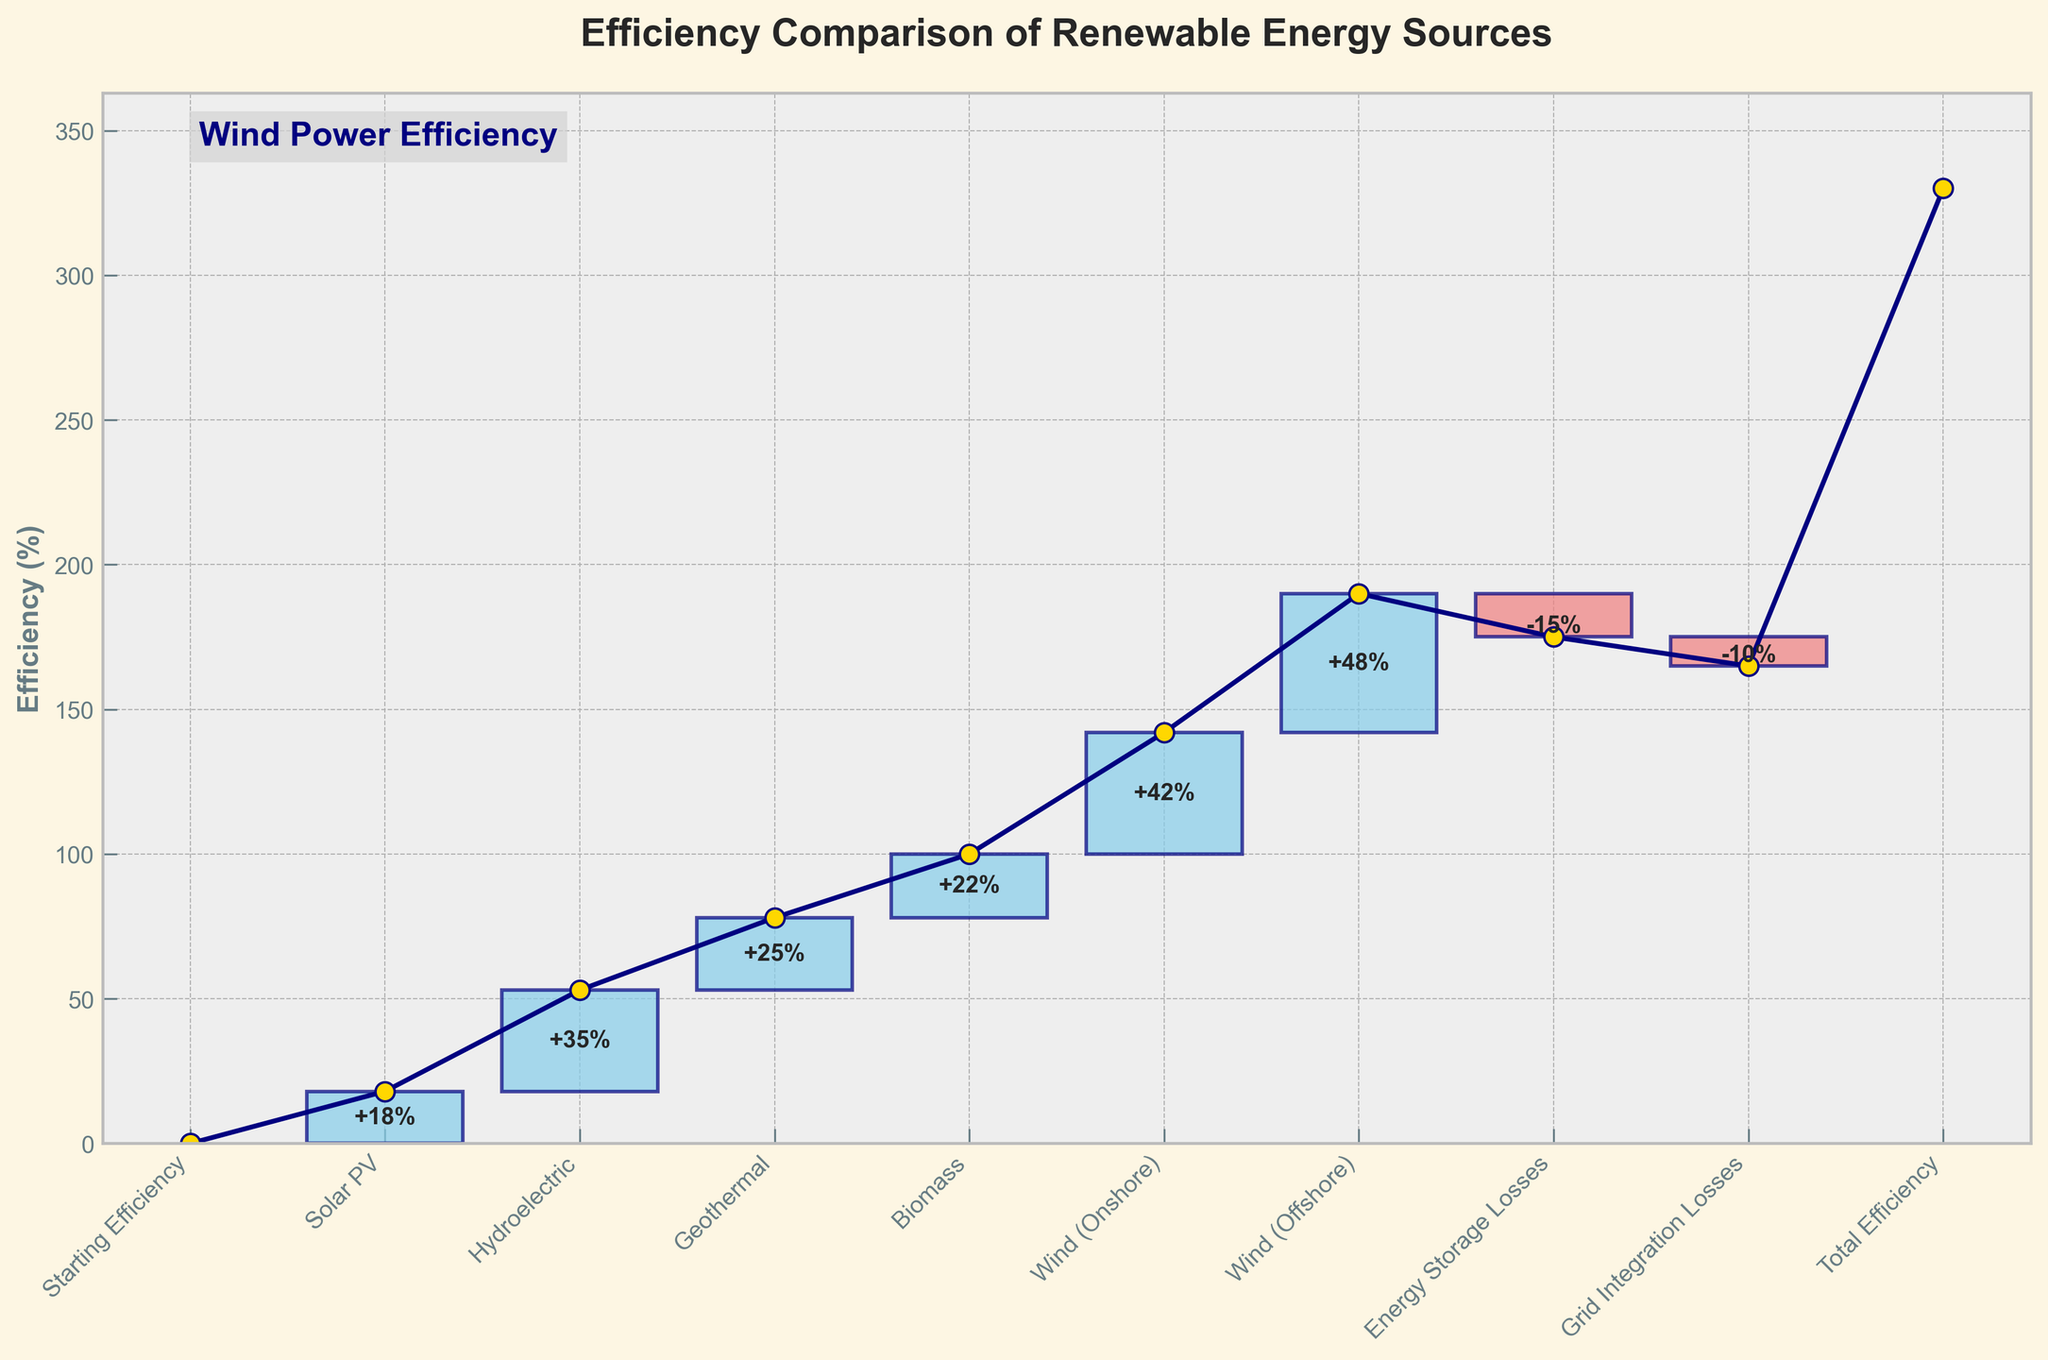Which renewable energy source has the highest efficiency according to the chart? The chart shows multiple renewable sources, but the highest efficiency is associated with the category having the tallest positive bar. From visual inspection, the tallest positive bar represents "Wind (Offshore)" with an efficiency increase of +48%.
Answer: Wind (Offshore) What is the total efficiency of renewable energy sources after considering losses? The chart's final bar represents the "Total Efficiency," combining all gains and losses. This bar ends at 165%, clearly shown on the chart.
Answer: 165% How does the efficiency of onshore wind compare to biomass? The Waterfall Chart shows individual bars for each category. The bar for "Wind (Onshore)" is +42%, while for "Biomass" it is +22%. Comparing these, onshore wind has a higher efficiency by 20%.
Answer: 20% What is the impact of energy storage losses on overall efficiency? The chart indicates a downward bar for "Energy Storage Losses" at -15%. This negative impact reduces the overall cumulative efficiency.
Answer: -15% What is the net change in efficiency when combining solar PV, hydroelectric, and geothermal? Summing the efficiencies of Solar PV (+18%), Hydroelectric (+35%), and Geothermal (+25%), we get a cumulative increase of 18 + 35 + 25 = 78%.
Answer: 78% Which category causes a decrease in overall efficiency, and by how much? The bars of the chart showing decreases are "Energy Storage Losses" (-15%) and "Grid Integration Losses" (-10%). Summing these gives a total efficiency decrease of -15 + -10 = -25%.
Answer: -25% How do the levels of efficiency between geothermal and hydroelectric compare? The bar for "Hydroelectric" is +35%, whereas for "Geothermal," it is +25%. Hydroelectric exceeds geothermal by 10%.
Answer: 10% What is the total positive contribution to efficiency before any losses are considered? Adding up all the positive contributions: Solar PV (+18%), Hydroelectric (+35%), Geothermal (+25%), Biomass (+22%), Wind (Onshore) (+42%), and Wind (Offshore) (+48%), we get 18 + 35 + 25 + 22 + 42 + 48 = 190%.
Answer: 190% What can be inferred about the relative contribution of wind power to overall efficiency? "Wind (Onshore)" at +42% and "Wind (Offshore)" at +48% are the two largest individual contributors to overall efficiency. Summing these up, wind power contributes 42 + 48 = 90%, which is significant in comparison to other sources.
Answer: 90% By how much does grid integration reduce the cumulative efficiency? The chart shows "Grid Integration Losses" as a negative bar at -10%. Therefore, grid integration reduces the cumulative efficiency by 10%.
Answer: 10% 